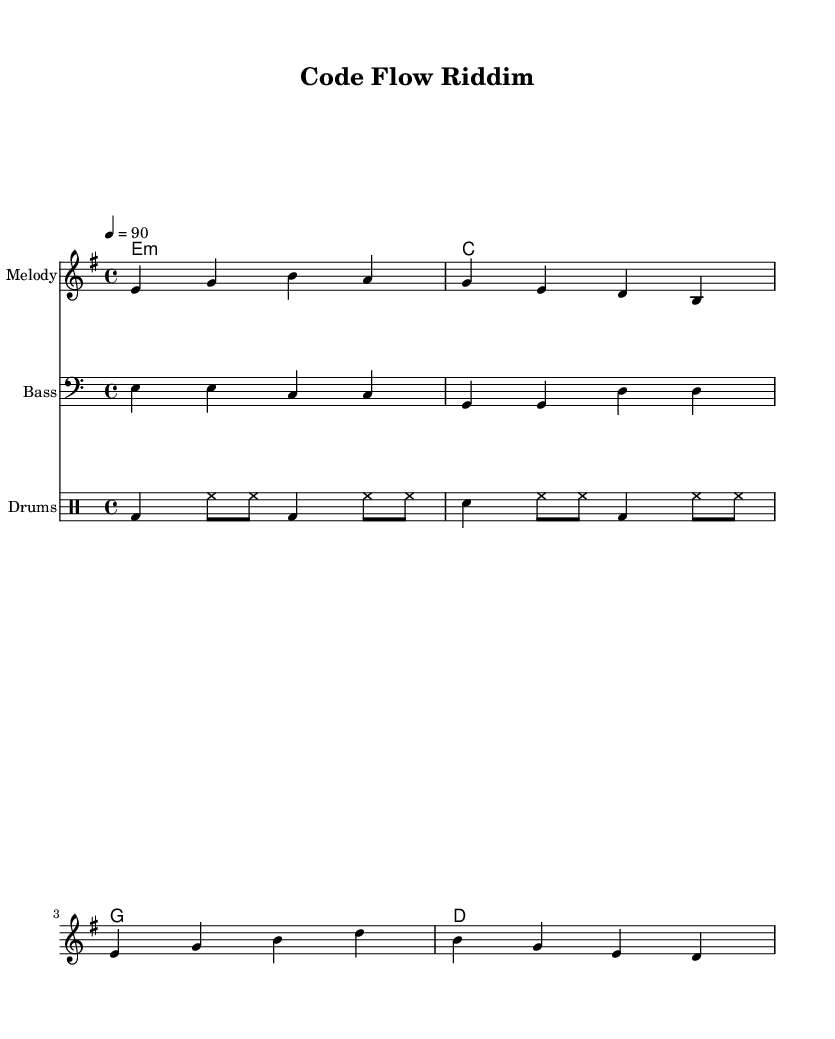What is the key signature of this music? The key signature is E minor, which has one sharp (F#) and indicates the tonality of the piece.
Answer: E minor What is the time signature of this music? The time signature is indicated at the beginning of the score as 4/4, meaning there are four beats per measure and the quarter note gets one beat.
Answer: 4/4 What is the tempo marking for this piece? The tempo marking is specified as quarter note equals 90, meaning the music should be played at a pace of 90 beats per minute.
Answer: 90 How many measures are in the melody? The melody section consists of 4 measures, each separated by a vertical line which indicates the end of a measure.
Answer: 4 What types of chords are used in the harmonies? The harmonies section includes a minor chord (E minor), a major chord (C), and additional major chords (G and D), reflecting the common use of different chord types in reggae music.
Answer: Minor and Major What is the rhythmic pattern for the drums? The drum patterns consist of varied beats including bass drum hits and snare drum hits, typical for preserving the reggae groove throughout the piece.
Answer: Bass and Snare What is a characteristic feature of reggae music evident in this piece? A characteristic feature in this piece is the offbeat skank played by the guitar or keyboard, which creates a relaxed feel that's fundamental to reggae.
Answer: Offbeat skank 